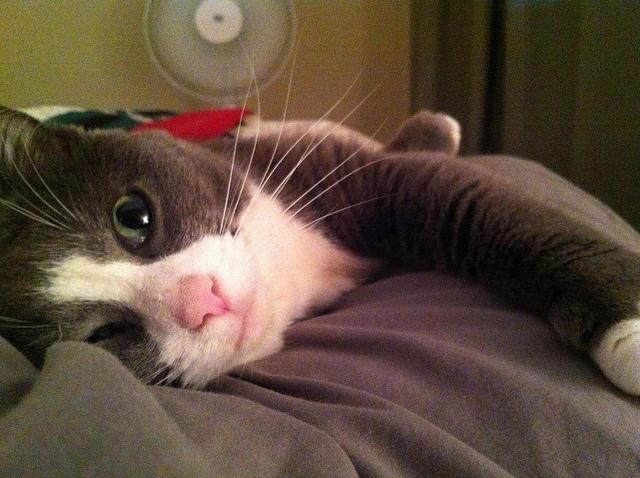Is the fan blowing?
Short answer required. Yes. Is the cat awake?
Give a very brief answer. Yes. What colors are the cat?
Answer briefly. Gray and white. 